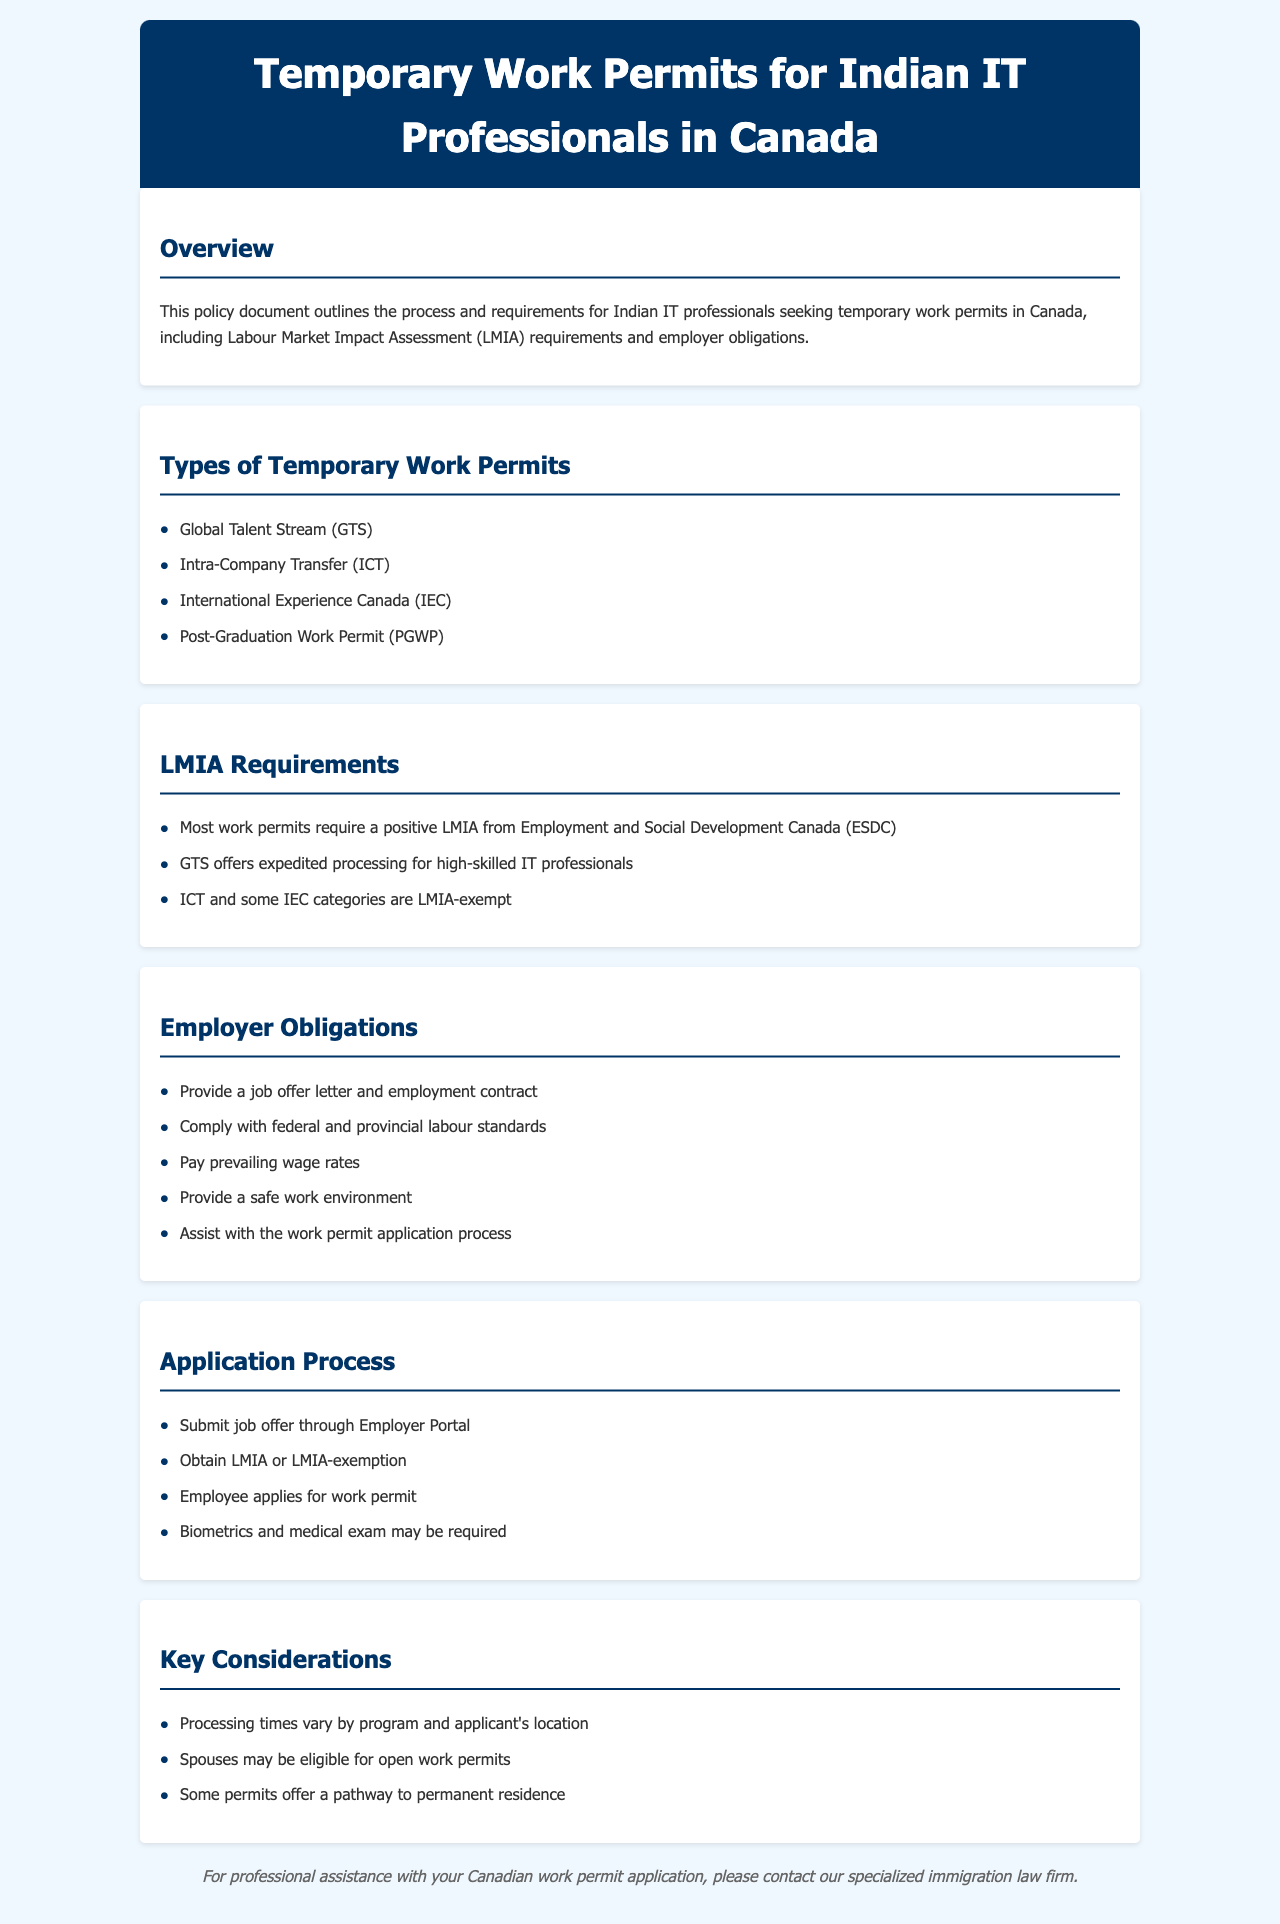What are the types of temporary work permits for IT professionals? The document lists the types of temporary work permits available for IT professionals in Canada.
Answer: Global Talent Stream, Intra-Company Transfer, International Experience Canada, Post-Graduation Work Permit What is required for most work permits? The document specifies that a positive LMIA from Employment and Social Development Canada is needed for most work permits.
Answer: Positive LMIA What does GTS offer for IT professionals? The document states that GTS provides expedited processing for high-skilled IT professionals.
Answer: Expedited processing Which categories are LMIA-exempt? The document mentions that ICT and some IEC categories do not require an LMIA.
Answer: ICT and some IEC categories What is one obligation of an employer? The document outlines several obligations, including providing a job offer letter.
Answer: Provide a job offer letter What may be required during the application process? The application process may include additional requirements specified in the document.
Answer: Biometrics and medical exam What may spouses be eligible for? The document indicates that spouses of applicants may be eligible for a certain type of work permit.
Answer: Open work permits What do some permits offer a pathway to? The document mentions that some work permits lead to further residency options.
Answer: Permanent residence 